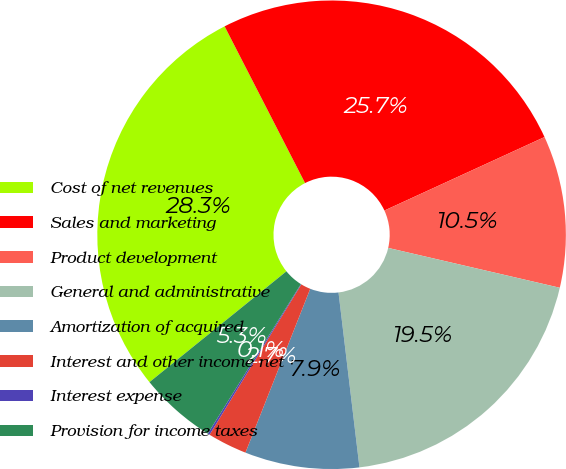Convert chart to OTSL. <chart><loc_0><loc_0><loc_500><loc_500><pie_chart><fcel>Cost of net revenues<fcel>Sales and marketing<fcel>Product development<fcel>General and administrative<fcel>Amortization of acquired<fcel>Interest and other income net<fcel>Interest expense<fcel>Provision for income taxes<nl><fcel>28.28%<fcel>25.7%<fcel>10.48%<fcel>19.47%<fcel>7.89%<fcel>2.73%<fcel>0.14%<fcel>5.31%<nl></chart> 